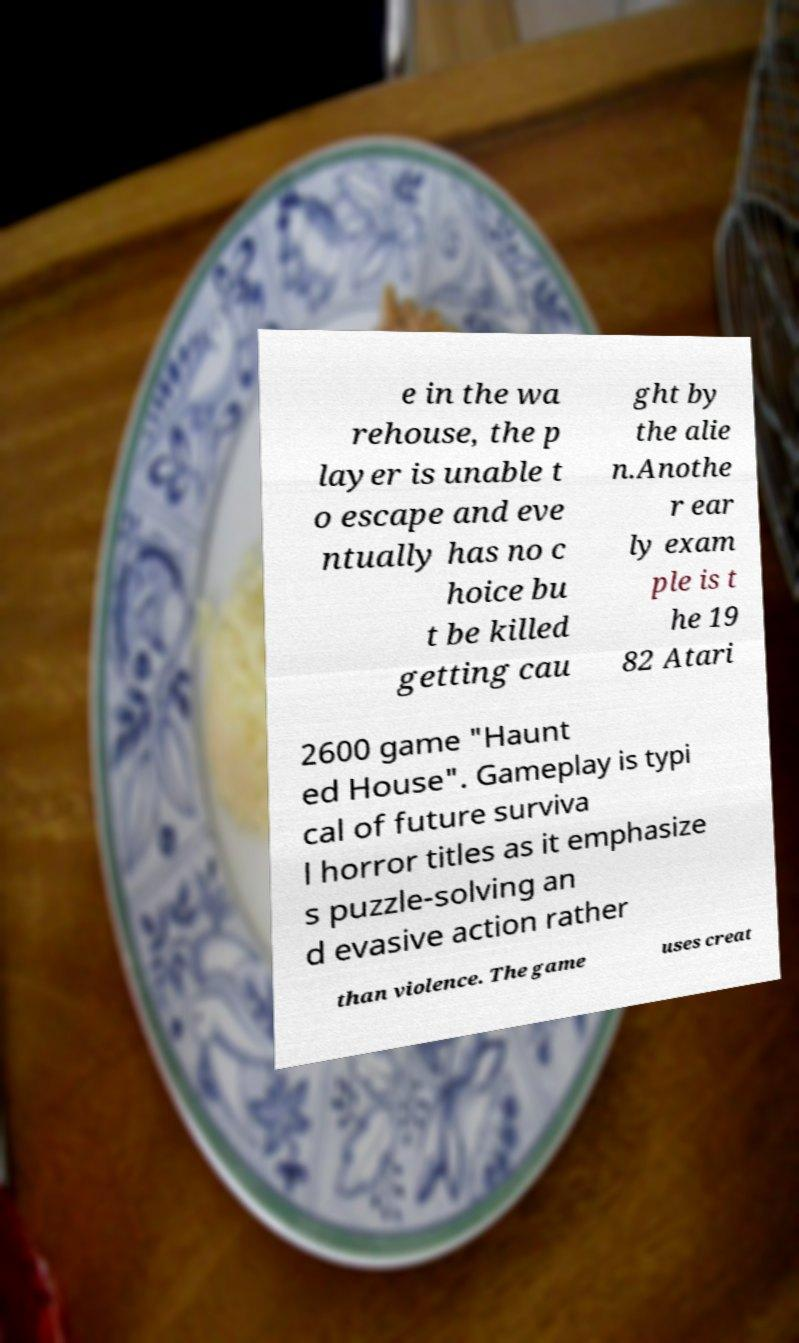Can you read and provide the text displayed in the image?This photo seems to have some interesting text. Can you extract and type it out for me? e in the wa rehouse, the p layer is unable t o escape and eve ntually has no c hoice bu t be killed getting cau ght by the alie n.Anothe r ear ly exam ple is t he 19 82 Atari 2600 game "Haunt ed House". Gameplay is typi cal of future surviva l horror titles as it emphasize s puzzle-solving an d evasive action rather than violence. The game uses creat 